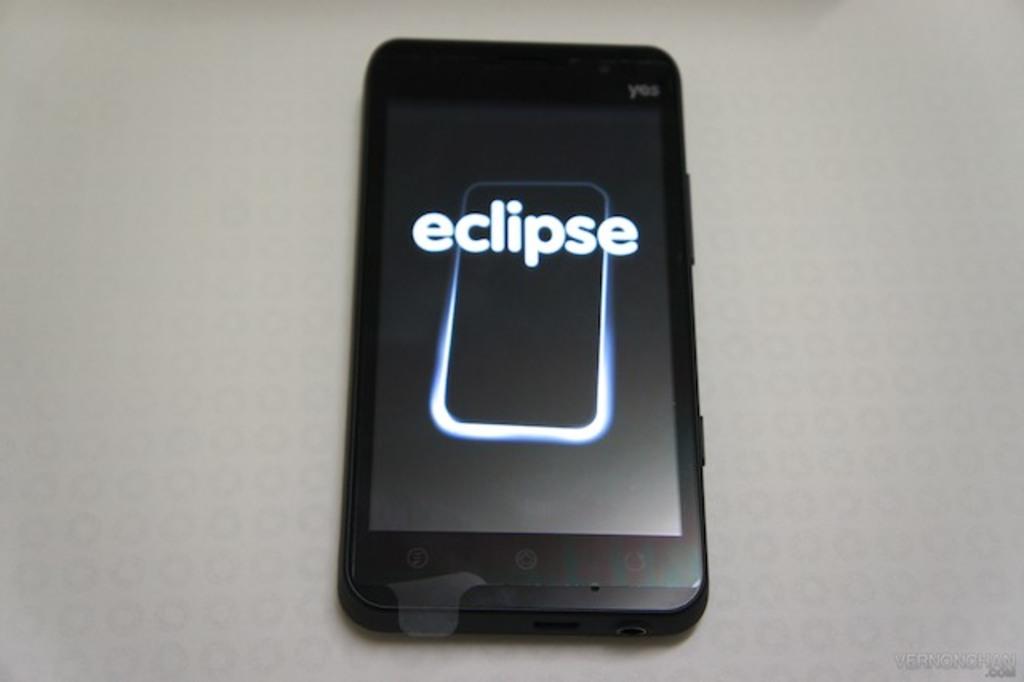What phenomenon is named on the phone background?
Offer a very short reply. Eclipse. 